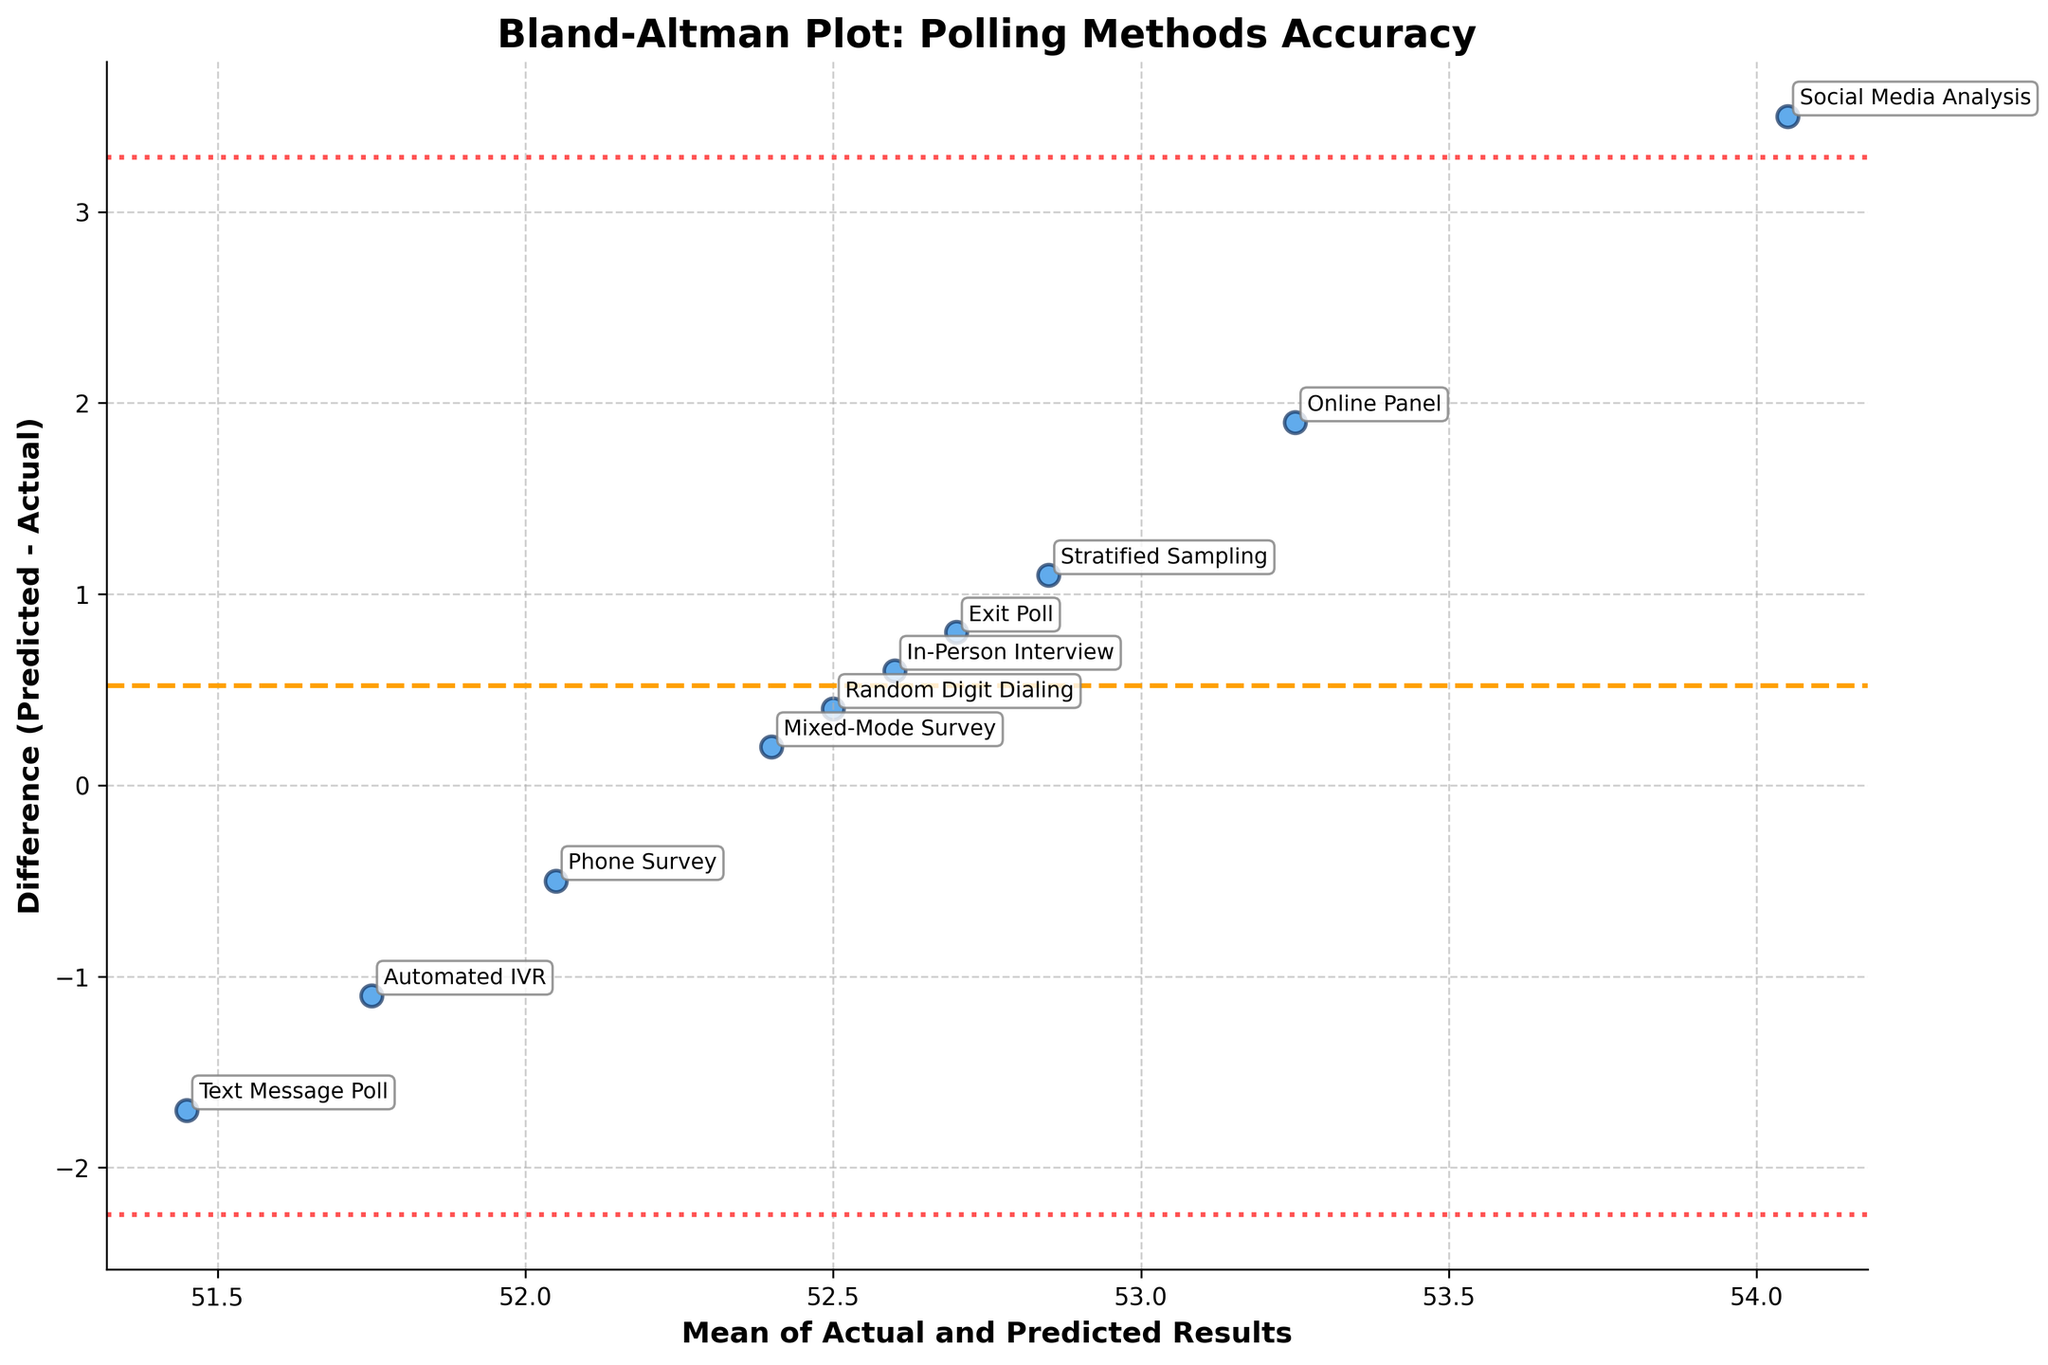What is the title of the plot? The title of the plot is located at the top of the figure and provides a brief description of the content. It is clearly visible and reads "Bland-Altman Plot: Polling Methods Accuracy".
Answer: Bland-Altman Plot: Polling Methods Accuracy How many data points are represented in the plot? Each polling method corresponds to a single data point on the plot. By counting the scatter points or the annotated methods in the figure, we can see there are 10 data points.
Answer: 10 Which polling method shows the largest positive difference between predicted and actual results? The largest positive difference is the point furthest above the horizontal line at zero on the y-axis. The method annotated next to this point is "Social Media Analysis" which is at approximately 3.5 units above the zero line.
Answer: Social Media Analysis What is the average of the differences between predicted and actual results? The average of the differences is shown as the horizontal dashed line. From the plot, this line is at y approximately equal to 0.28.
Answer: 0.28 Which polling method predicted the election outcome the most accurately? The most accurate prediction will have the smallest absolute difference (absolute value of predicted minus actual). The data point closest to the zero horizontal line is "Random Digit Dialing" which has a difference close to 0.4 units from zero.
Answer: Random Digit Dialing What are the limits of agreement, and where do they lie in relation to the mean difference line? Limits of agreement are the lines at ±1.96 times the standard deviation from the mean difference. They are represented by the dotted lines. Based on the figure, these limits seem to be around y = 1.96 and y = -1.4.
Answer: ±1.96 and -1.4 Which polling method had the lowest predicted result, and what is the mean of the actual and predicted results for that method? The lowest predicted result can be identified by the lowest scatter point on the y-axis. The method is "Text Message Poll" and its predicted result is approximately 50.6. The mean of the actual (52.3) and predicted (50.6) results for this method is (52.3 + 50.6)/2 = 51.45.
Answer: Text Message Poll, mean = 51.45 Did any of the polling methods have a negative difference? If so, which? Points below the horizontal line at zero have a negative difference. Methods annotated next to points below zero are "Phone Survey," "Text Message Poll," and "Automated IVR" indicating these had negative differences.
Answer: Phone Survey, Text Message Poll, Automated IVR Which two polling methods showed the largest discrepancies from the actual result, and what are those discrepancies? The largest discrepancies are the points furthest above or below the zero line on the y-axis. "Social Media Analysis" and "Text Message Poll" show the largest deviations, with differences of approximately +3.5 and -1.7 units respectively.
Answer: Social Media Analysis (+3.5), Text Message Poll (-1.7) 